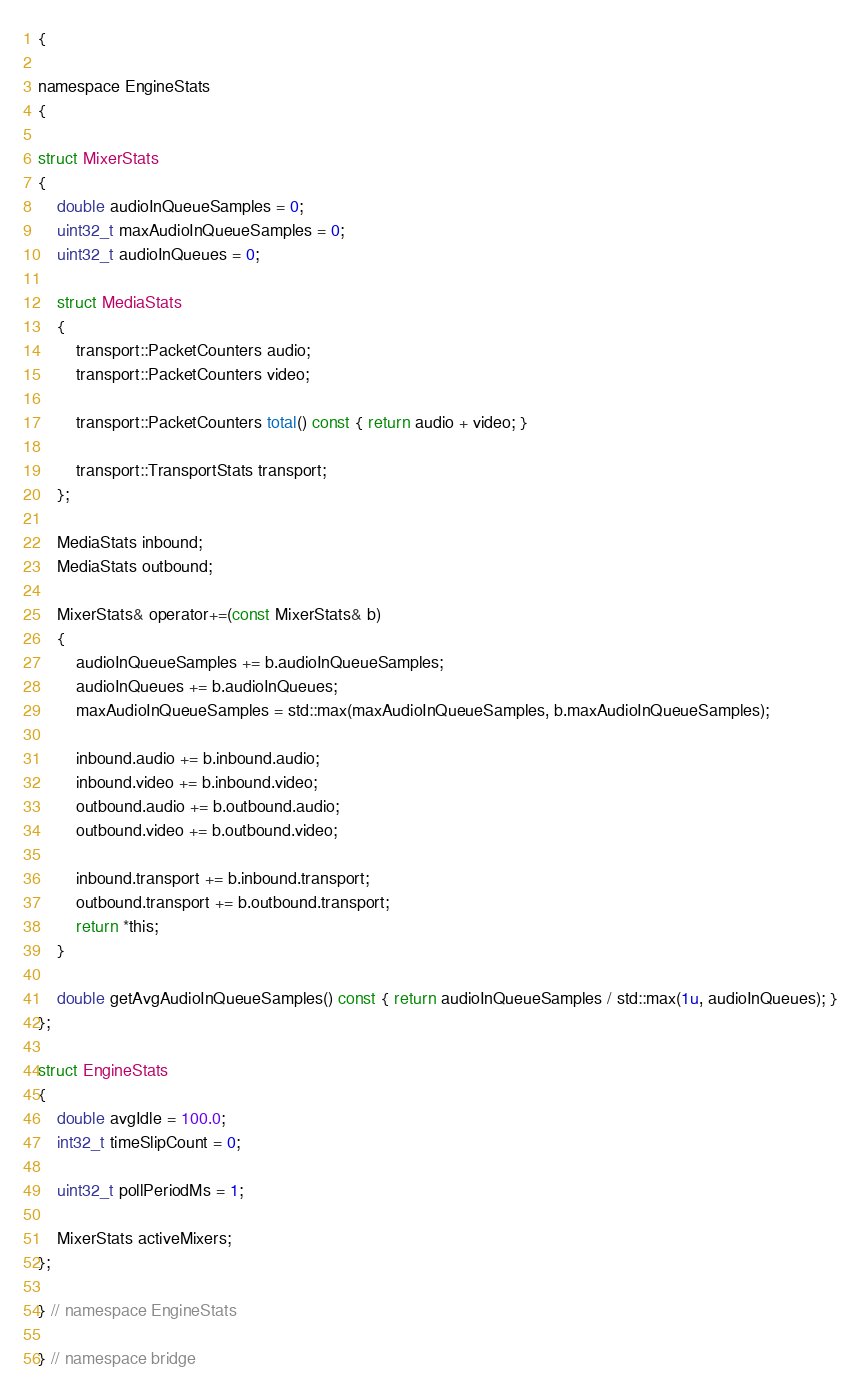Convert code to text. <code><loc_0><loc_0><loc_500><loc_500><_C_>{

namespace EngineStats
{

struct MixerStats
{
    double audioInQueueSamples = 0;
    uint32_t maxAudioInQueueSamples = 0;
    uint32_t audioInQueues = 0;

    struct MediaStats
    {
        transport::PacketCounters audio;
        transport::PacketCounters video;

        transport::PacketCounters total() const { return audio + video; }

        transport::TransportStats transport;
    };

    MediaStats inbound;
    MediaStats outbound;

    MixerStats& operator+=(const MixerStats& b)
    {
        audioInQueueSamples += b.audioInQueueSamples;
        audioInQueues += b.audioInQueues;
        maxAudioInQueueSamples = std::max(maxAudioInQueueSamples, b.maxAudioInQueueSamples);

        inbound.audio += b.inbound.audio;
        inbound.video += b.inbound.video;
        outbound.audio += b.outbound.audio;
        outbound.video += b.outbound.video;

        inbound.transport += b.inbound.transport;
        outbound.transport += b.outbound.transport;
        return *this;
    }

    double getAvgAudioInQueueSamples() const { return audioInQueueSamples / std::max(1u, audioInQueues); }
};

struct EngineStats
{
    double avgIdle = 100.0;
    int32_t timeSlipCount = 0;

    uint32_t pollPeriodMs = 1;

    MixerStats activeMixers;
};

} // namespace EngineStats

} // namespace bridge
</code> 